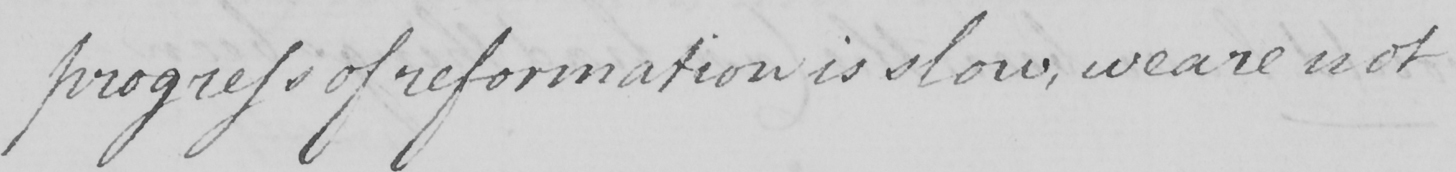What does this handwritten line say? progress of reformation is slow , we are not 